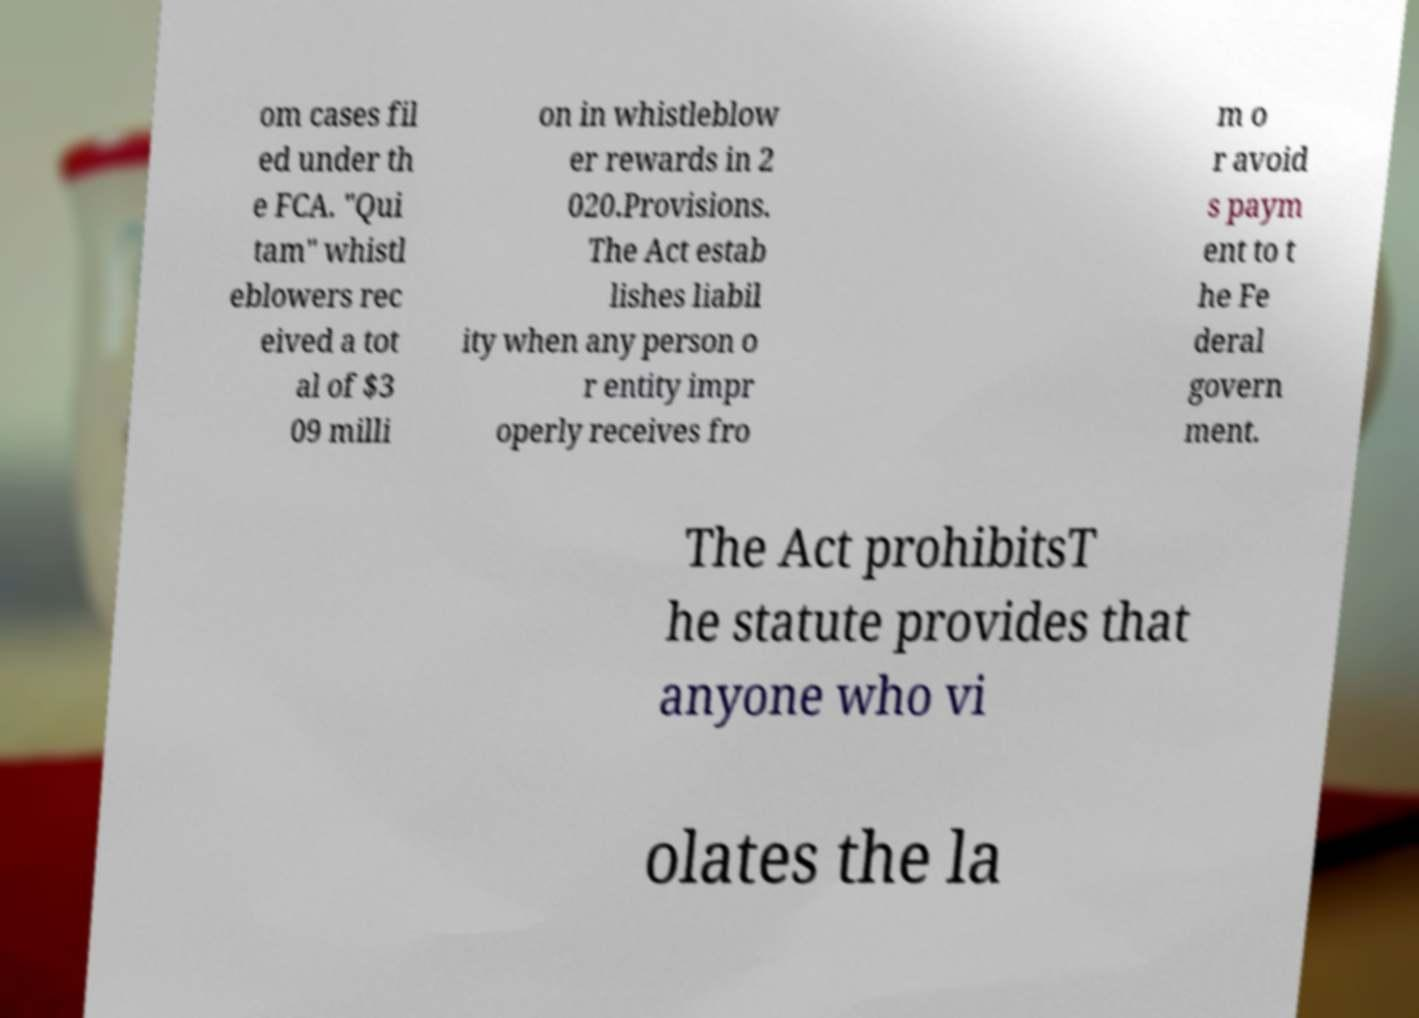What messages or text are displayed in this image? I need them in a readable, typed format. om cases fil ed under th e FCA. "Qui tam" whistl eblowers rec eived a tot al of $3 09 milli on in whistleblow er rewards in 2 020.Provisions. The Act estab lishes liabil ity when any person o r entity impr operly receives fro m o r avoid s paym ent to t he Fe deral govern ment. The Act prohibitsT he statute provides that anyone who vi olates the la 